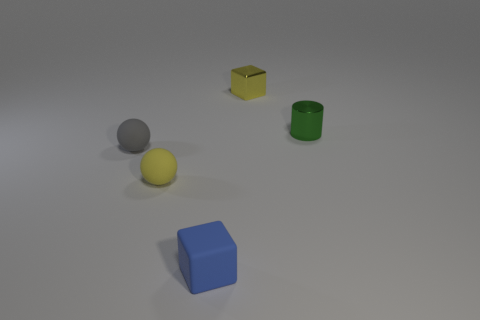How is the lighting in the image affecting the appearance of the objects? The lighting in the image is subtle and diffused, casting soft shadows and allowing the true colors of the objects to be clearly visible without harsh reflections or glare. 